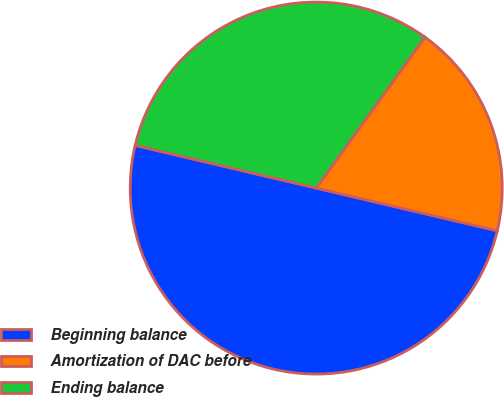Convert chart. <chart><loc_0><loc_0><loc_500><loc_500><pie_chart><fcel>Beginning balance<fcel>Amortization of DAC before<fcel>Ending balance<nl><fcel>50.0%<fcel>18.75%<fcel>31.25%<nl></chart> 